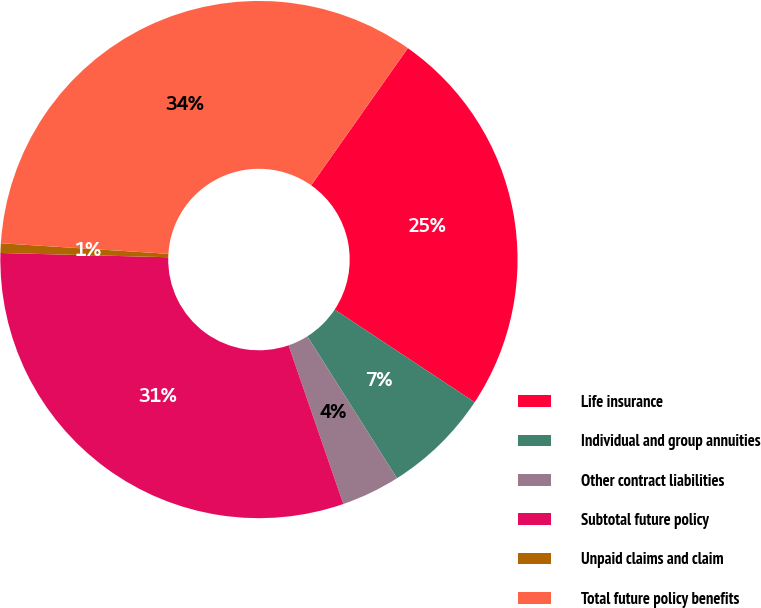<chart> <loc_0><loc_0><loc_500><loc_500><pie_chart><fcel>Life insurance<fcel>Individual and group annuities<fcel>Other contract liabilities<fcel>Subtotal future policy<fcel>Unpaid claims and claim<fcel>Total future policy benefits<nl><fcel>24.53%<fcel>6.74%<fcel>3.67%<fcel>30.69%<fcel>0.6%<fcel>33.76%<nl></chart> 